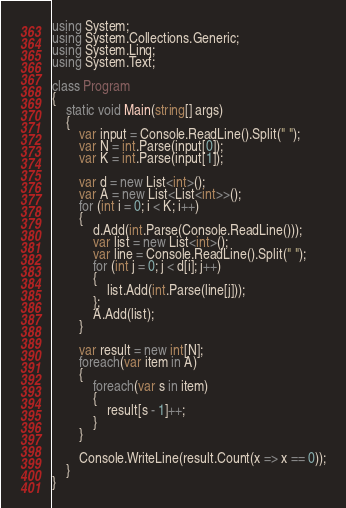Convert code to text. <code><loc_0><loc_0><loc_500><loc_500><_C#_>using System;
using System.Collections.Generic;
using System.Linq;
using System.Text;

class Program
{
    static void Main(string[] args)
    {
        var input = Console.ReadLine().Split(" ");
        var N = int.Parse(input[0]);
        var K = int.Parse(input[1]);

        var d = new List<int>();
        var A = new List<List<int>>();
        for (int i = 0; i < K; i++)
        {
            d.Add(int.Parse(Console.ReadLine()));
            var list = new List<int>();
            var line = Console.ReadLine().Split(" ");
            for (int j = 0; j < d[i]; j++)
            {
                list.Add(int.Parse(line[j]));
            };
            A.Add(list);
        }

        var result = new int[N];
        foreach(var item in A)
        {
            foreach(var s in item)
            {
                result[s - 1]++;
            }
        }

        Console.WriteLine(result.Count(x => x == 0));
    }
}
</code> 